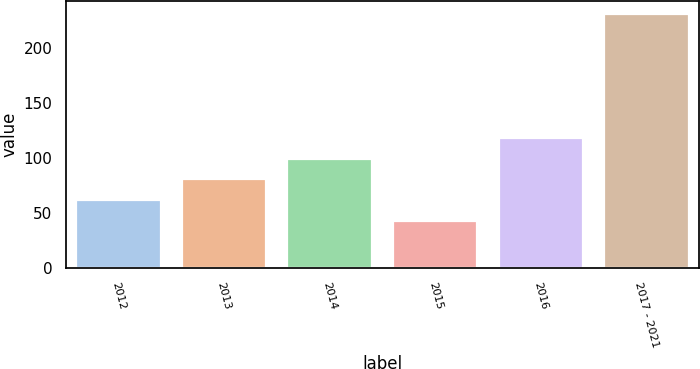Convert chart. <chart><loc_0><loc_0><loc_500><loc_500><bar_chart><fcel>2012<fcel>2013<fcel>2014<fcel>2015<fcel>2016<fcel>2017 - 2021<nl><fcel>61.8<fcel>80.6<fcel>99.4<fcel>43<fcel>118.2<fcel>231<nl></chart> 